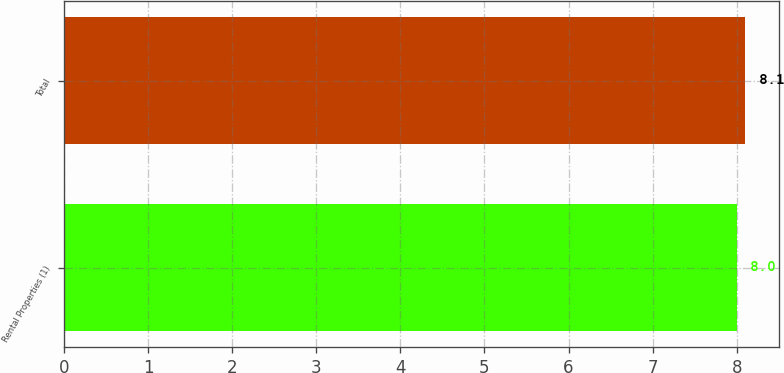Convert chart to OTSL. <chart><loc_0><loc_0><loc_500><loc_500><bar_chart><fcel>Rental Properties (1)<fcel>Total<nl><fcel>8<fcel>8.1<nl></chart> 